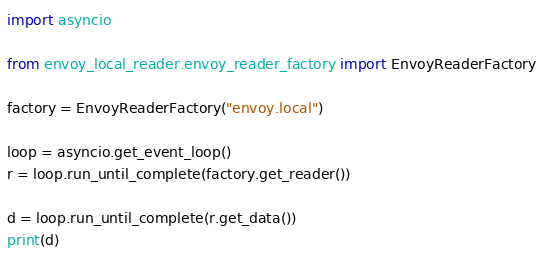Convert code to text. <code><loc_0><loc_0><loc_500><loc_500><_Python_>import asyncio

from envoy_local_reader.envoy_reader_factory import EnvoyReaderFactory

factory = EnvoyReaderFactory("envoy.local")

loop = asyncio.get_event_loop()
r = loop.run_until_complete(factory.get_reader())

d = loop.run_until_complete(r.get_data())
print(d)
</code> 